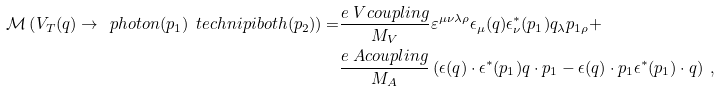Convert formula to latex. <formula><loc_0><loc_0><loc_500><loc_500>\mathcal { M } \left ( V _ { T } ( q ) \to \ p h o t o n ( p _ { 1 } ) \ t e c h n i p i b o t h ( p _ { 2 } ) \right ) = & \frac { e \ V c o u p l i n g } { M _ { V } } \varepsilon ^ { \mu \nu \lambda \rho } \epsilon _ { \mu } ( q ) \epsilon ^ { * } _ { \nu } ( p _ { 1 } ) q _ { \lambda } p _ { 1 \rho } + \\ & \frac { e \ A c o u p l i n g } { M _ { A } } \left ( \epsilon ( q ) \cdot \epsilon ^ { * } ( p _ { 1 } ) q \cdot p _ { 1 } - \epsilon ( q ) \cdot p _ { 1 } \epsilon ^ { * } ( p _ { 1 } ) \cdot q \right ) \ ,</formula> 